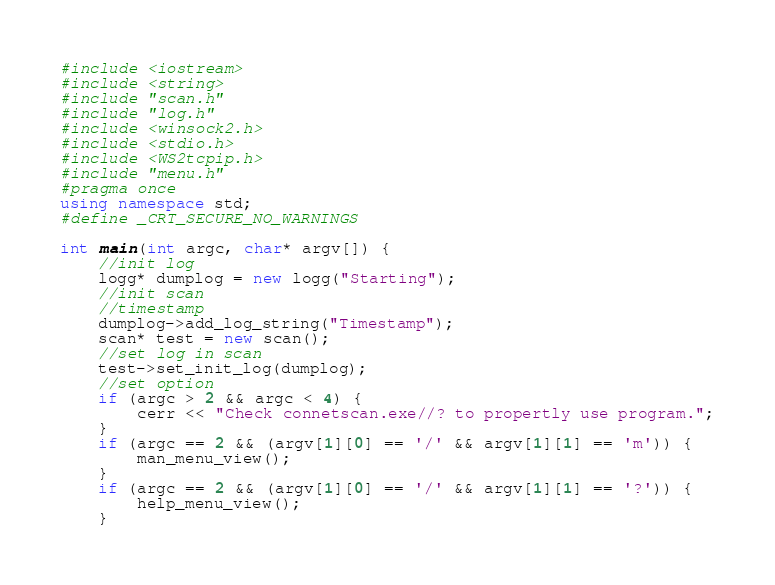Convert code to text. <code><loc_0><loc_0><loc_500><loc_500><_C++_>#include <iostream>
#include <string>
#include "scan.h"
#include "log.h"
#include <winsock2.h>
#include <stdio.h>
#include <WS2tcpip.h>
#include "menu.h"
#pragma once
using namespace std;
#define _CRT_SECURE_NO_WARNINGS

int main(int argc, char* argv[]) {
	//init log
	logg* dumplog = new logg("Starting");
	//init scan
	//timestamp
	dumplog->add_log_string("Timestamp");
	scan* test = new scan();
	//set log in scan
	test->set_init_log(dumplog);
	//set option
	if (argc > 2 && argc < 4) {
		cerr << "Check connetscan.exe//? to propertly use program.";
	}
	if (argc == 2 && (argv[1][0] == '/' && argv[1][1] == 'm')) {
		man_menu_view();
	}
	if (argc == 2 && (argv[1][0] == '/' && argv[1][1] == '?')) {
		help_menu_view();
	}</code> 